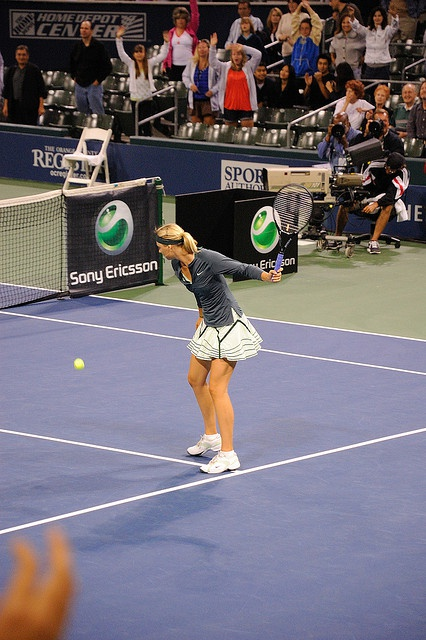Describe the objects in this image and their specific colors. I can see people in black, maroon, darkgray, and gray tones, people in black, ivory, orange, and gray tones, people in black, brown, salmon, and tan tones, people in black, gray, and maroon tones, and people in black, maroon, brown, and darkgray tones in this image. 